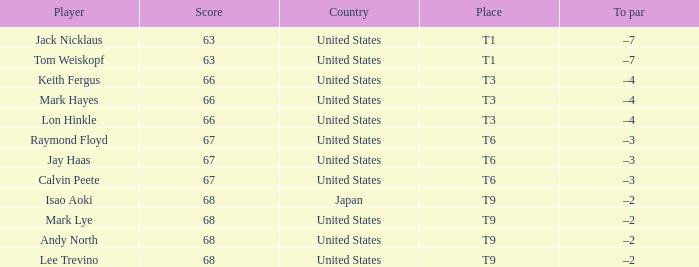What is the Country, when Place is T6, and when Player is "Raymond Floyd"? United States. Can you give me this table as a dict? {'header': ['Player', 'Score', 'Country', 'Place', 'To par'], 'rows': [['Jack Nicklaus', '63', 'United States', 'T1', '–7'], ['Tom Weiskopf', '63', 'United States', 'T1', '–7'], ['Keith Fergus', '66', 'United States', 'T3', '–4'], ['Mark Hayes', '66', 'United States', 'T3', '–4'], ['Lon Hinkle', '66', 'United States', 'T3', '–4'], ['Raymond Floyd', '67', 'United States', 'T6', '–3'], ['Jay Haas', '67', 'United States', 'T6', '–3'], ['Calvin Peete', '67', 'United States', 'T6', '–3'], ['Isao Aoki', '68', 'Japan', 'T9', '–2'], ['Mark Lye', '68', 'United States', 'T9', '–2'], ['Andy North', '68', 'United States', 'T9', '–2'], ['Lee Trevino', '68', 'United States', 'T9', '–2']]} 